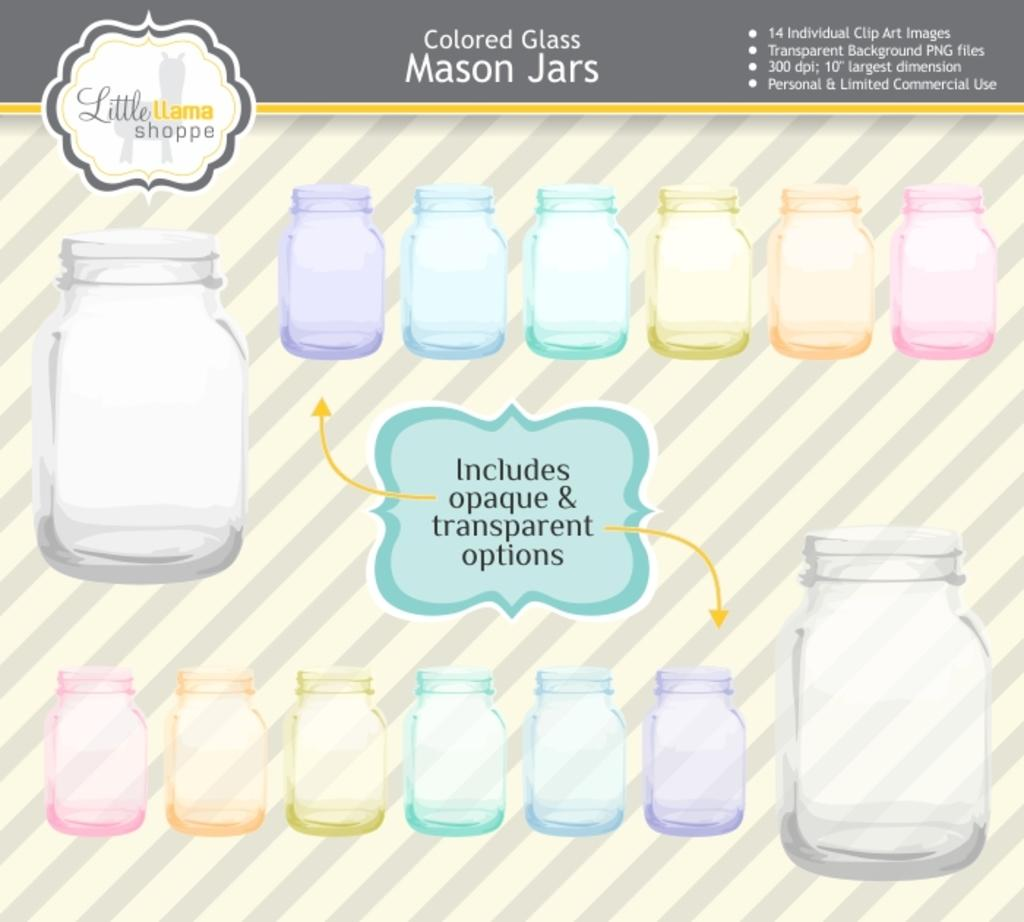<image>
Summarize the visual content of the image. An advertisement for colored Mason jars, they can be transparent. 